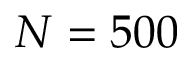Convert formula to latex. <formula><loc_0><loc_0><loc_500><loc_500>N = 5 0 0</formula> 